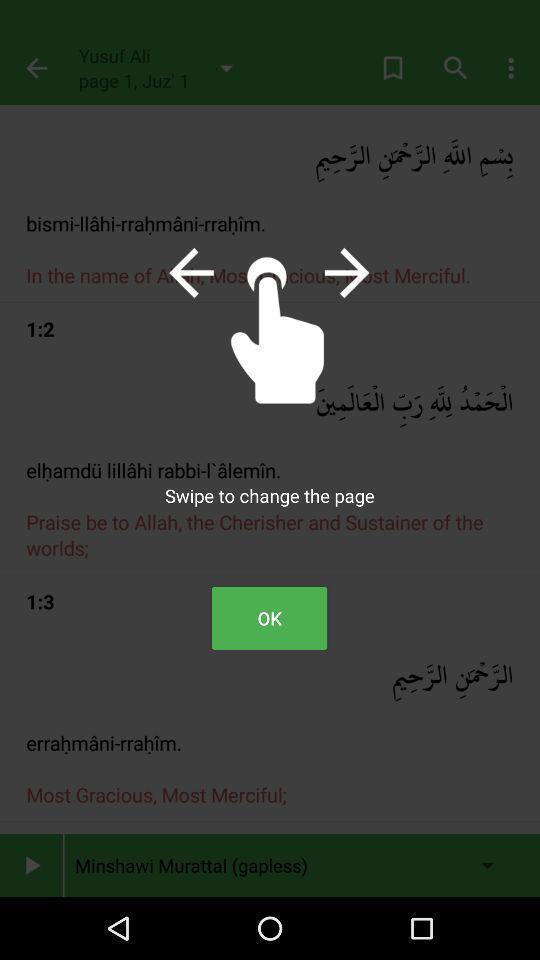What is the overall content of this screenshot? Screen shows information of religious app. 